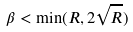Convert formula to latex. <formula><loc_0><loc_0><loc_500><loc_500>\beta < \min ( R , 2 \sqrt { R } )</formula> 